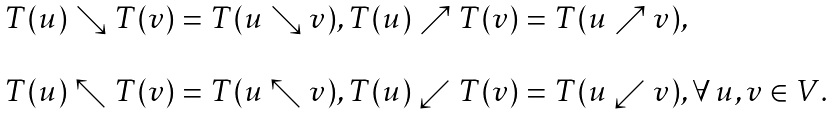Convert formula to latex. <formula><loc_0><loc_0><loc_500><loc_500>\begin{array} { r c l } & & T ( u ) \searrow T ( v ) = T ( u \searrow v ) , T ( u ) \nearrow T ( v ) = T ( u \nearrow v ) , \\ \\ & & T ( u ) \nwarrow T ( v ) = T ( u \nwarrow v ) , T ( u ) \swarrow T ( v ) = T ( u \swarrow v ) , \forall \, u , v \in V . \end{array}</formula> 